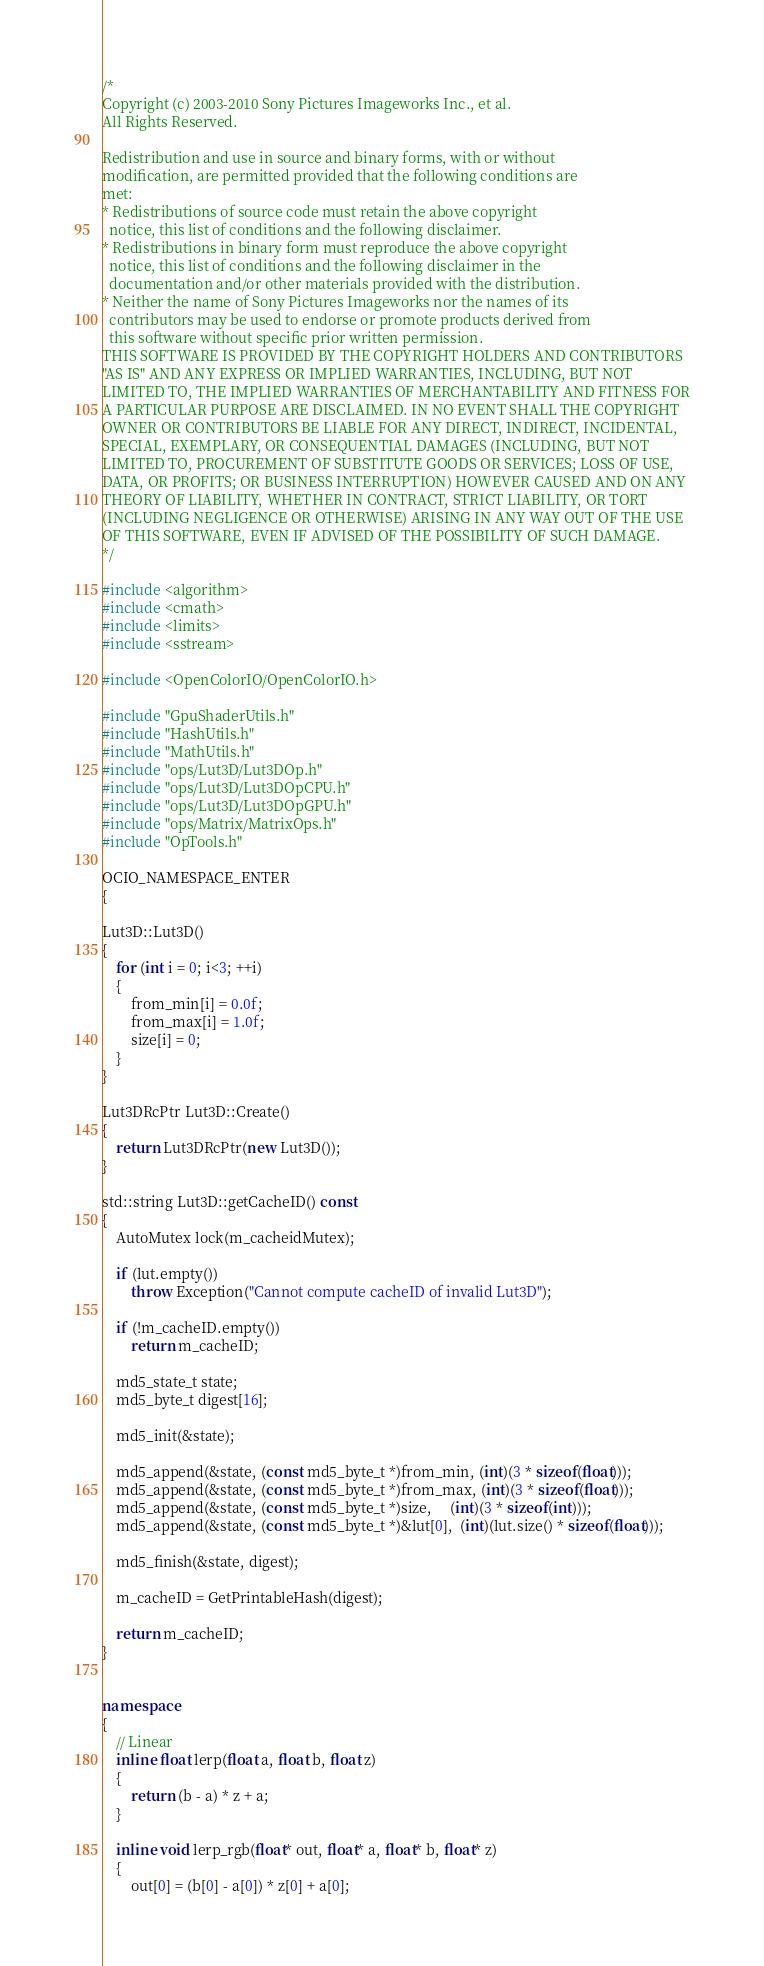<code> <loc_0><loc_0><loc_500><loc_500><_C++_>/*
Copyright (c) 2003-2010 Sony Pictures Imageworks Inc., et al.
All Rights Reserved.

Redistribution and use in source and binary forms, with or without
modification, are permitted provided that the following conditions are
met:
* Redistributions of source code must retain the above copyright
  notice, this list of conditions and the following disclaimer.
* Redistributions in binary form must reproduce the above copyright
  notice, this list of conditions and the following disclaimer in the
  documentation and/or other materials provided with the distribution.
* Neither the name of Sony Pictures Imageworks nor the names of its
  contributors may be used to endorse or promote products derived from
  this software without specific prior written permission.
THIS SOFTWARE IS PROVIDED BY THE COPYRIGHT HOLDERS AND CONTRIBUTORS
"AS IS" AND ANY EXPRESS OR IMPLIED WARRANTIES, INCLUDING, BUT NOT
LIMITED TO, THE IMPLIED WARRANTIES OF MERCHANTABILITY AND FITNESS FOR
A PARTICULAR PURPOSE ARE DISCLAIMED. IN NO EVENT SHALL THE COPYRIGHT
OWNER OR CONTRIBUTORS BE LIABLE FOR ANY DIRECT, INDIRECT, INCIDENTAL,
SPECIAL, EXEMPLARY, OR CONSEQUENTIAL DAMAGES (INCLUDING, BUT NOT
LIMITED TO, PROCUREMENT OF SUBSTITUTE GOODS OR SERVICES; LOSS OF USE,
DATA, OR PROFITS; OR BUSINESS INTERRUPTION) HOWEVER CAUSED AND ON ANY
THEORY OF LIABILITY, WHETHER IN CONTRACT, STRICT LIABILITY, OR TORT
(INCLUDING NEGLIGENCE OR OTHERWISE) ARISING IN ANY WAY OUT OF THE USE
OF THIS SOFTWARE, EVEN IF ADVISED OF THE POSSIBILITY OF SUCH DAMAGE.
*/

#include <algorithm>
#include <cmath>
#include <limits>
#include <sstream>

#include <OpenColorIO/OpenColorIO.h>

#include "GpuShaderUtils.h"
#include "HashUtils.h"
#include "MathUtils.h"
#include "ops/Lut3D/Lut3DOp.h"
#include "ops/Lut3D/Lut3DOpCPU.h"
#include "ops/Lut3D/Lut3DOpGPU.h"
#include "ops/Matrix/MatrixOps.h"
#include "OpTools.h"

OCIO_NAMESPACE_ENTER
{

Lut3D::Lut3D()
{
    for (int i = 0; i<3; ++i)
    {
        from_min[i] = 0.0f;
        from_max[i] = 1.0f;
        size[i] = 0;
    }
}

Lut3DRcPtr Lut3D::Create()
{
    return Lut3DRcPtr(new Lut3D());
}

std::string Lut3D::getCacheID() const
{
    AutoMutex lock(m_cacheidMutex);

    if (lut.empty())
        throw Exception("Cannot compute cacheID of invalid Lut3D");

    if (!m_cacheID.empty())
        return m_cacheID;

    md5_state_t state;
    md5_byte_t digest[16];

    md5_init(&state);

    md5_append(&state, (const md5_byte_t *)from_min, (int)(3 * sizeof(float)));
    md5_append(&state, (const md5_byte_t *)from_max, (int)(3 * sizeof(float)));
    md5_append(&state, (const md5_byte_t *)size,     (int)(3 * sizeof(int)));
    md5_append(&state, (const md5_byte_t *)&lut[0],  (int)(lut.size() * sizeof(float)));

    md5_finish(&state, digest);

    m_cacheID = GetPrintableHash(digest);

    return m_cacheID;
}


namespace
{
    // Linear
    inline float lerp(float a, float b, float z)
    {
        return (b - a) * z + a;
    }

    inline void lerp_rgb(float* out, float* a, float* b, float* z)
    {
        out[0] = (b[0] - a[0]) * z[0] + a[0];</code> 